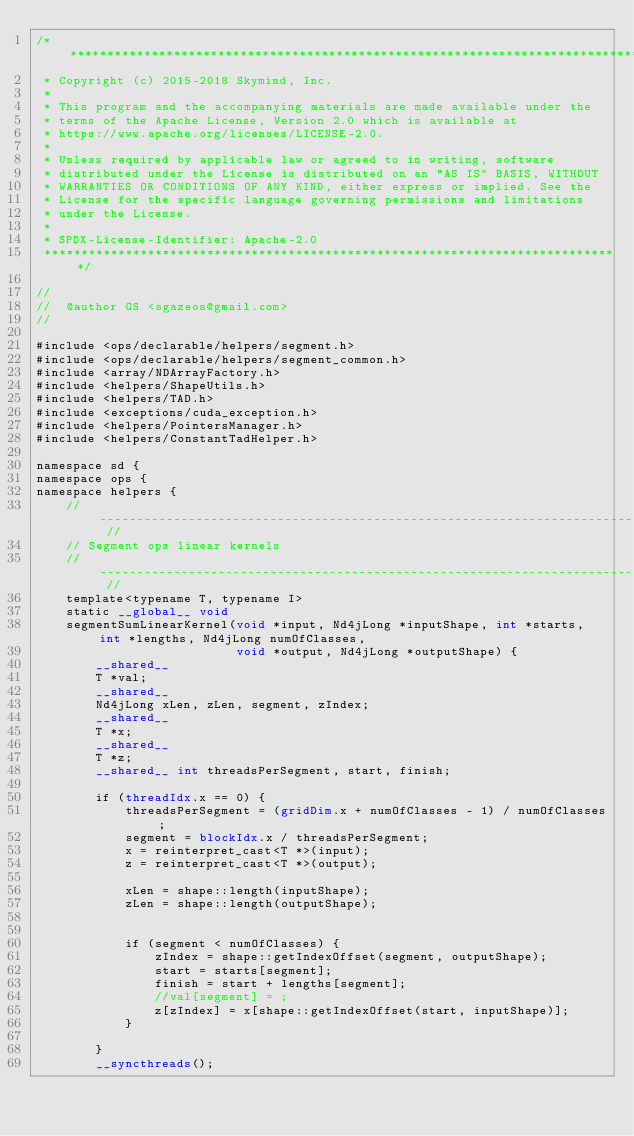Convert code to text. <code><loc_0><loc_0><loc_500><loc_500><_Cuda_>/*******************************************************************************
 * Copyright (c) 2015-2018 Skymind, Inc.
 *
 * This program and the accompanying materials are made available under the
 * terms of the Apache License, Version 2.0 which is available at
 * https://www.apache.org/licenses/LICENSE-2.0.
 *
 * Unless required by applicable law or agreed to in writing, software
 * distributed under the License is distributed on an "AS IS" BASIS, WITHOUT
 * WARRANTIES OR CONDITIONS OF ANY KIND, either express or implied. See the
 * License for the specific language governing permissions and limitations
 * under the License.
 *
 * SPDX-License-Identifier: Apache-2.0
 ******************************************************************************/

//
//  @author GS <sgazeos@gmail.com>
//

#include <ops/declarable/helpers/segment.h>
#include <ops/declarable/helpers/segment_common.h>
#include <array/NDArrayFactory.h>
#include <helpers/ShapeUtils.h>
#include <helpers/TAD.h>
#include <exceptions/cuda_exception.h>
#include <helpers/PointersManager.h>
#include <helpers/ConstantTadHelper.h>

namespace sd {
namespace ops {
namespace helpers {
    // -------------------------------------------------------------------------------------------------------------- //
    // Segment ops linear kernels
    // -------------------------------------------------------------------------------------------------------------- //
    template<typename T, typename I>
    static __global__ void
    segmentSumLinearKernel(void *input, Nd4jLong *inputShape, int *starts, int *lengths, Nd4jLong numOfClasses,
                           void *output, Nd4jLong *outputShape) {
        __shared__
        T *val;
        __shared__
        Nd4jLong xLen, zLen, segment, zIndex;
        __shared__
        T *x;
        __shared__
        T *z;
        __shared__ int threadsPerSegment, start, finish;

        if (threadIdx.x == 0) {
            threadsPerSegment = (gridDim.x + numOfClasses - 1) / numOfClasses;
            segment = blockIdx.x / threadsPerSegment;
            x = reinterpret_cast<T *>(input);
            z = reinterpret_cast<T *>(output);

            xLen = shape::length(inputShape);
            zLen = shape::length(outputShape);


            if (segment < numOfClasses) {
                zIndex = shape::getIndexOffset(segment, outputShape);
                start = starts[segment];
                finish = start + lengths[segment];
                //val[segment] = ;
                z[zIndex] = x[shape::getIndexOffset(start, inputShape)];
            }

        }
        __syncthreads();
</code> 